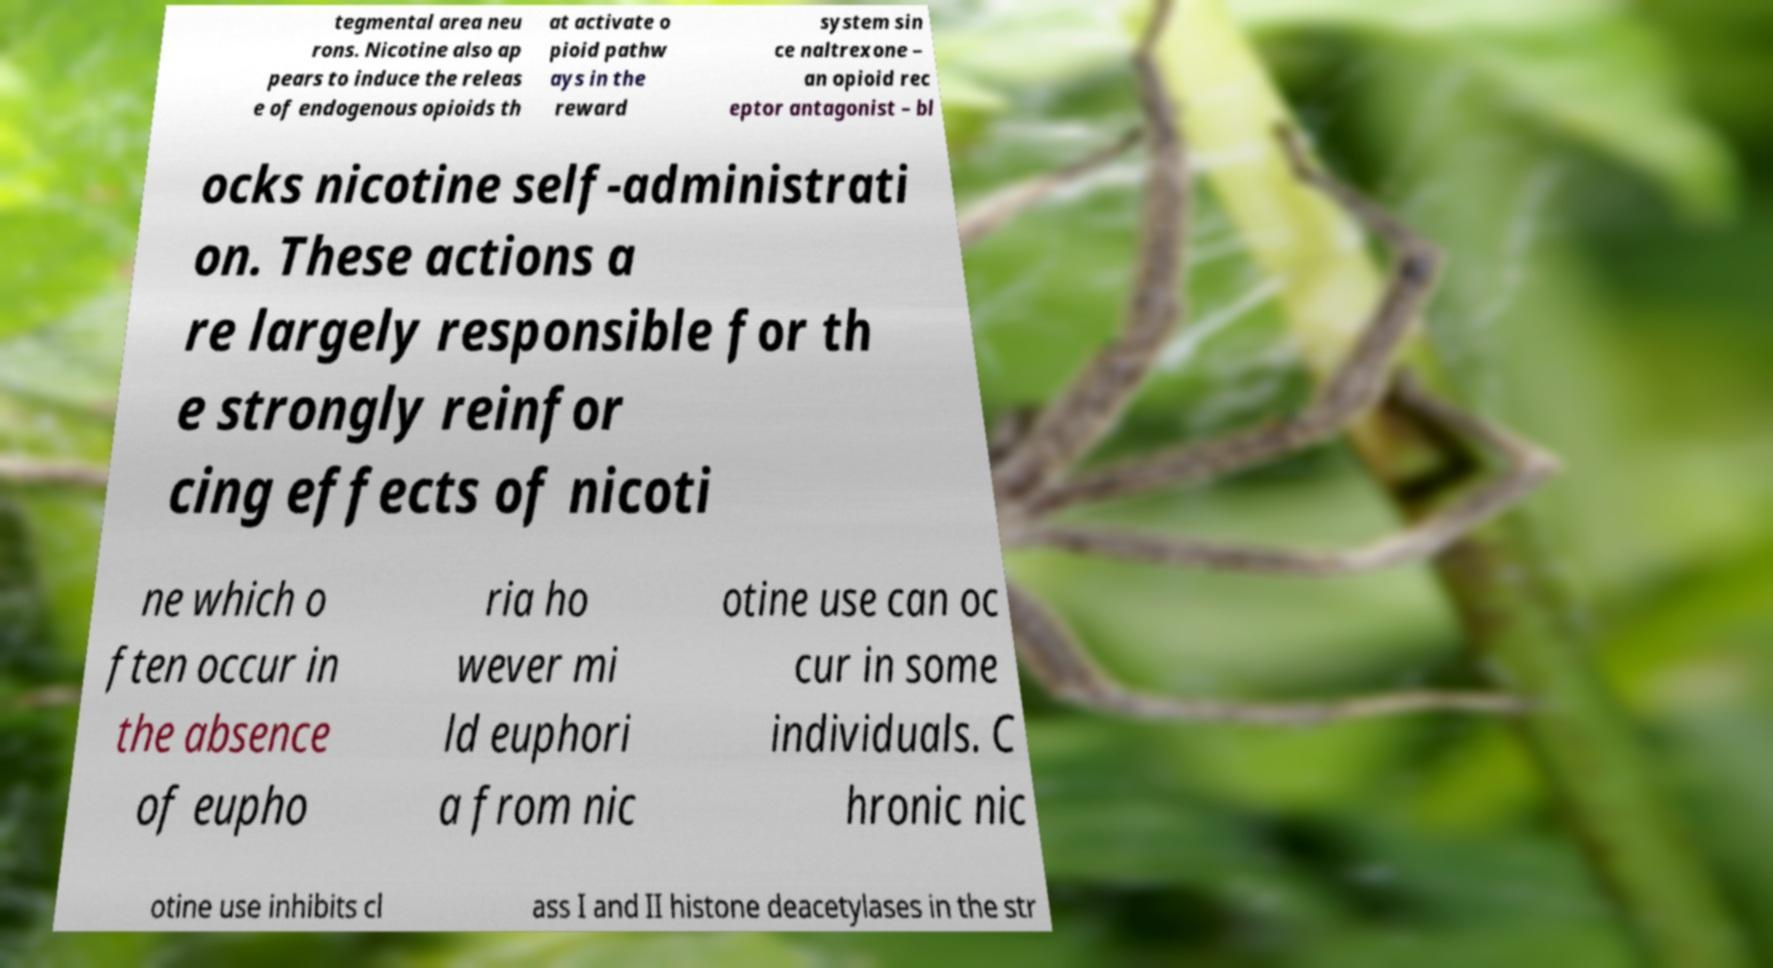What messages or text are displayed in this image? I need them in a readable, typed format. tegmental area neu rons. Nicotine also ap pears to induce the releas e of endogenous opioids th at activate o pioid pathw ays in the reward system sin ce naltrexone – an opioid rec eptor antagonist – bl ocks nicotine self-administrati on. These actions a re largely responsible for th e strongly reinfor cing effects of nicoti ne which o ften occur in the absence of eupho ria ho wever mi ld euphori a from nic otine use can oc cur in some individuals. C hronic nic otine use inhibits cl ass I and II histone deacetylases in the str 